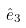Convert formula to latex. <formula><loc_0><loc_0><loc_500><loc_500>\hat { e } _ { 3 }</formula> 